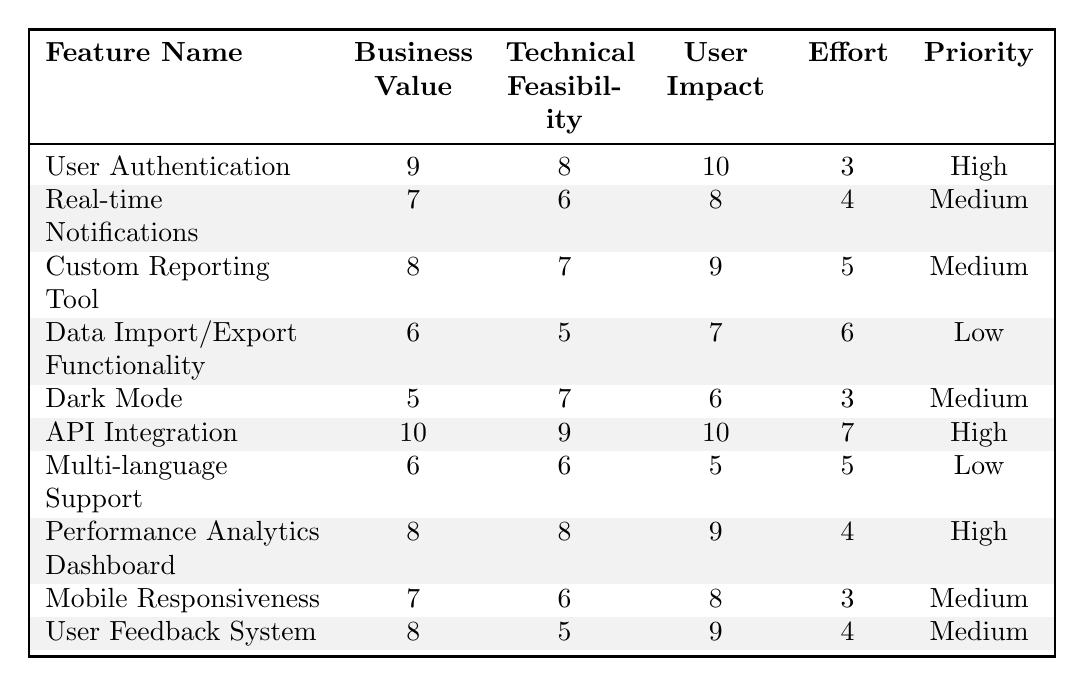What is the priority of the "User Authentication" feature? The "User Authentication" feature has a priority level listed in the table, which is specified under the "Priority" column. It states "High."
Answer: High How many features have a "Low" priority? The "Priority" column shows the following features with "Low" priority: Data Import/Export Functionality and Multi-language Support. This counts as 2 features.
Answer: 2 What is the Business Value of "API Integration"? In the table, the "Business Value" for "API Integration" is directly given in the corresponding column, which is 10.
Answer: 10 Which feature has the highest User Impact score? The highest User Impact score in the table is 10, associated with the features "User Authentication" and "API Integration."
Answer: User Authentication and API Integration What is the average Effort score for Medium priority features? The Effort scores for Medium priority features are 4 (Real-time Notifications) + 5 (Custom Reporting Tool) + 3 (Dark Mode) + 3 (Mobile Responsiveness) + 4 (User Feedback System) totaling 19. There are 5 features, so the average is 19/5 = 3.8.
Answer: 3.8 Is "Dark Mode" technically feasible? The table indicates that "Dark Mode" has a Technical Feasibility score of 7, which indicates that it is technically feasible.
Answer: Yes What is the difference in Business Value between the highest and lowest scoring features? The highest Business Value is 10 (API Integration), and the lowest is 5 (Dark Mode). The difference is 10 - 5 = 5.
Answer: 5 Which feature has both the highest Technical Feasibility and the highest User Impact? The "API Integration" feature has the highest Technical Feasibility score of 9 and also a User Impact score of 10, indicating it meets both criteria.
Answer: API Integration If we sum the Business Values of all features, what is the total? The Business Values are: 9 + 7 + 8 + 6 + 5 + 10 + 6 + 8 + 7 + 8 which sums to 79.
Answer: 79 How many features have a User Impact score greater than 8? The features with a User Impact score greater than 8 are "User Authentication" (10), "API Integration" (10), "Custom Reporting Tool" (9), and "Performance Analytics Dashboard" (9). This gives a total of 4 features.
Answer: 4 